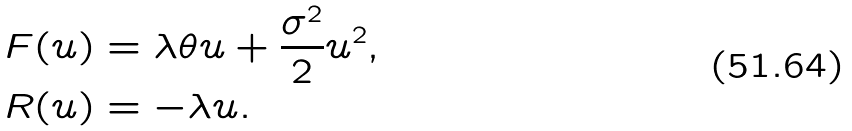<formula> <loc_0><loc_0><loc_500><loc_500>F ( u ) & = \lambda \theta u + \frac { \sigma ^ { 2 } } { 2 } u ^ { 2 } , \\ R ( u ) & = - \lambda u .</formula> 